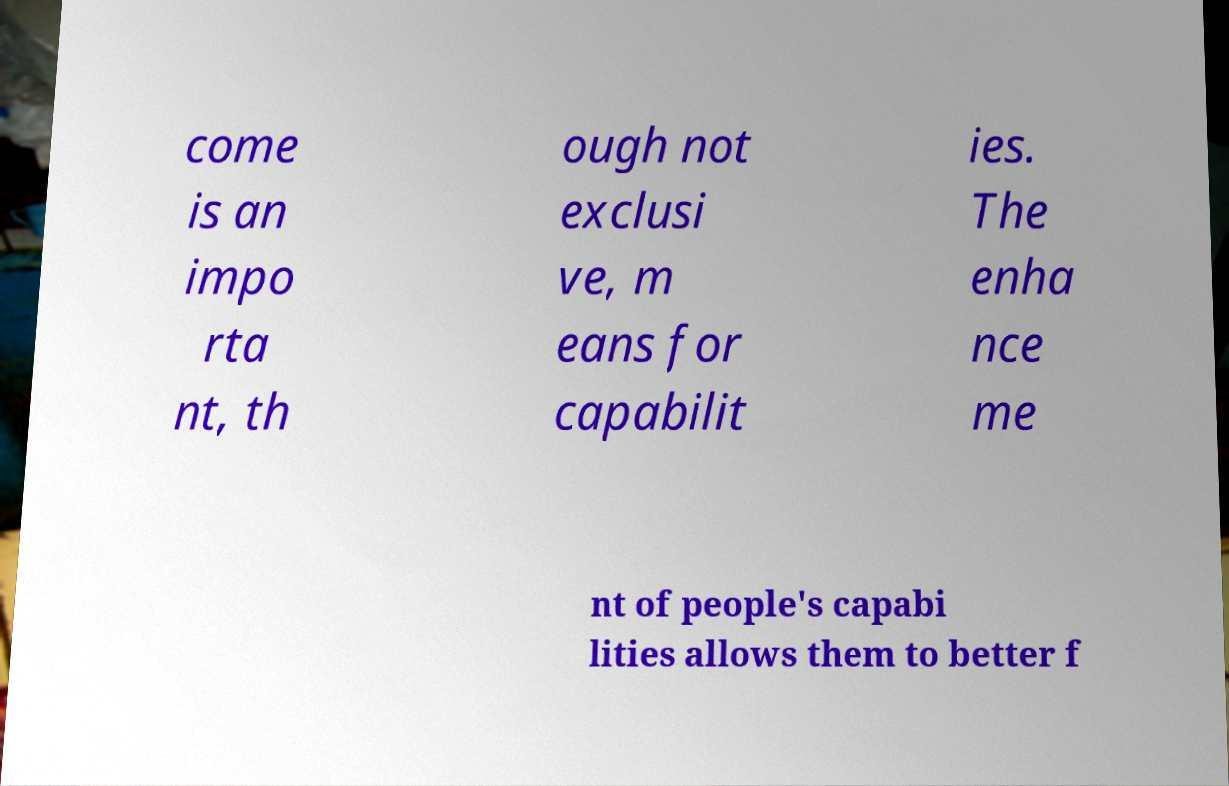Please read and relay the text visible in this image. What does it say? come is an impo rta nt, th ough not exclusi ve, m eans for capabilit ies. The enha nce me nt of people's capabi lities allows them to better f 